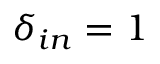<formula> <loc_0><loc_0><loc_500><loc_500>\delta _ { i n } = 1</formula> 